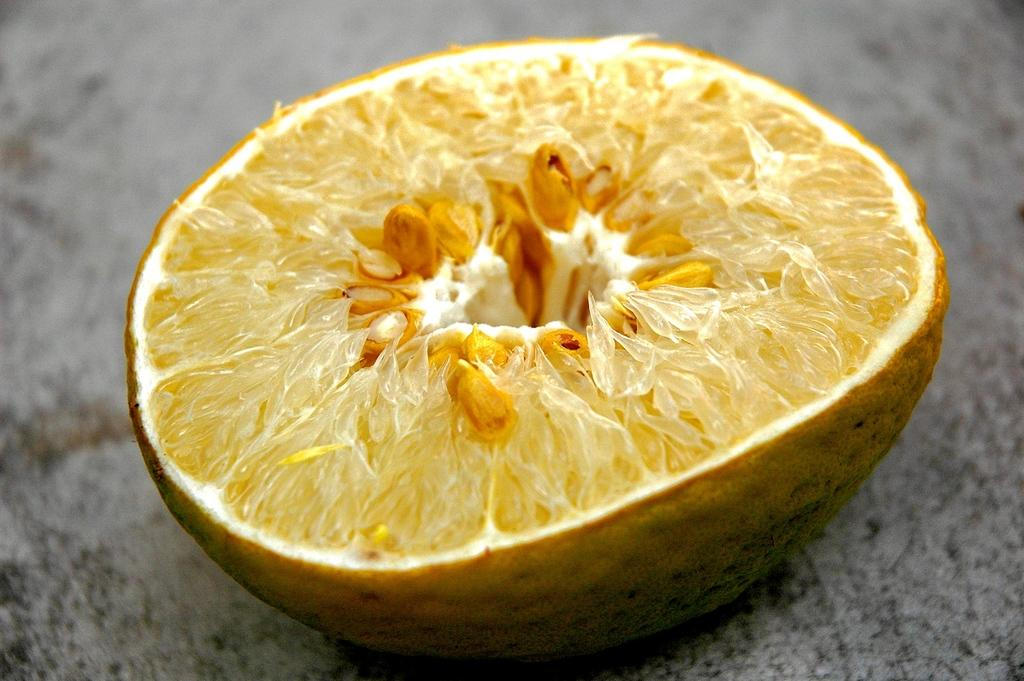What is the main object in the image? There is a piece of lemon in the image. Where is the piece of lemon located? The piece of lemon is present over a place. What type of muscle is visible in the image? There is no muscle visible in the image; it only features a piece of lemon. 